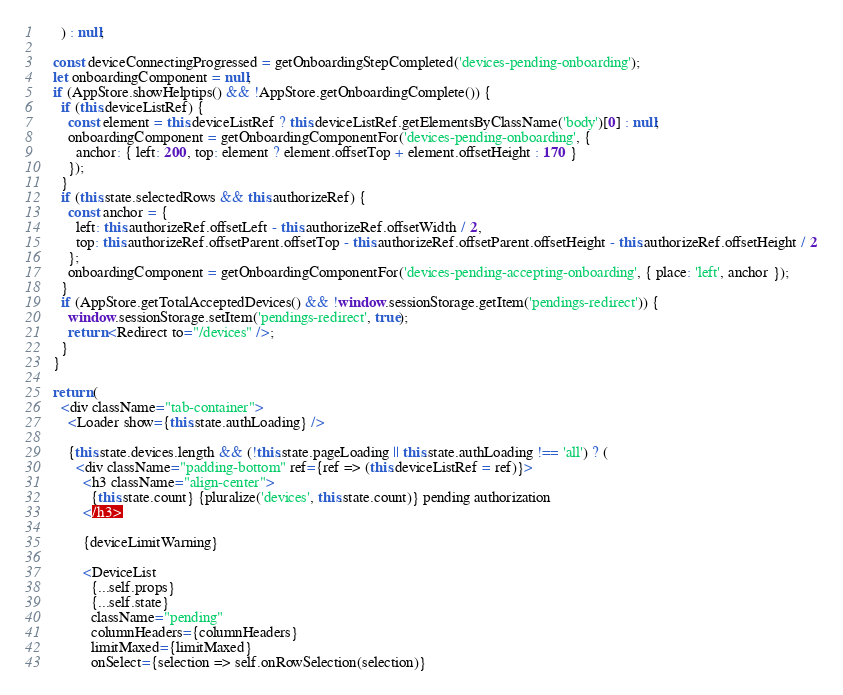Convert code to text. <code><loc_0><loc_0><loc_500><loc_500><_JavaScript_>      ) : null;

    const deviceConnectingProgressed = getOnboardingStepCompleted('devices-pending-onboarding');
    let onboardingComponent = null;
    if (AppStore.showHelptips() && !AppStore.getOnboardingComplete()) {
      if (this.deviceListRef) {
        const element = this.deviceListRef ? this.deviceListRef.getElementsByClassName('body')[0] : null;
        onboardingComponent = getOnboardingComponentFor('devices-pending-onboarding', {
          anchor: { left: 200, top: element ? element.offsetTop + element.offsetHeight : 170 }
        });
      }
      if (this.state.selectedRows && this.authorizeRef) {
        const anchor = {
          left: this.authorizeRef.offsetLeft - this.authorizeRef.offsetWidth / 2,
          top: this.authorizeRef.offsetParent.offsetTop - this.authorizeRef.offsetParent.offsetHeight - this.authorizeRef.offsetHeight / 2
        };
        onboardingComponent = getOnboardingComponentFor('devices-pending-accepting-onboarding', { place: 'left', anchor });
      }
      if (AppStore.getTotalAcceptedDevices() && !window.sessionStorage.getItem('pendings-redirect')) {
        window.sessionStorage.setItem('pendings-redirect', true);
        return <Redirect to="/devices" />;
      }
    }

    return (
      <div className="tab-container">
        <Loader show={this.state.authLoading} />

        {this.state.devices.length && (!this.state.pageLoading || this.state.authLoading !== 'all') ? (
          <div className="padding-bottom" ref={ref => (this.deviceListRef = ref)}>
            <h3 className="align-center">
              {this.state.count} {pluralize('devices', this.state.count)} pending authorization
            </h3>

            {deviceLimitWarning}

            <DeviceList
              {...self.props}
              {...self.state}
              className="pending"
              columnHeaders={columnHeaders}
              limitMaxed={limitMaxed}
              onSelect={selection => self.onRowSelection(selection)}</code> 